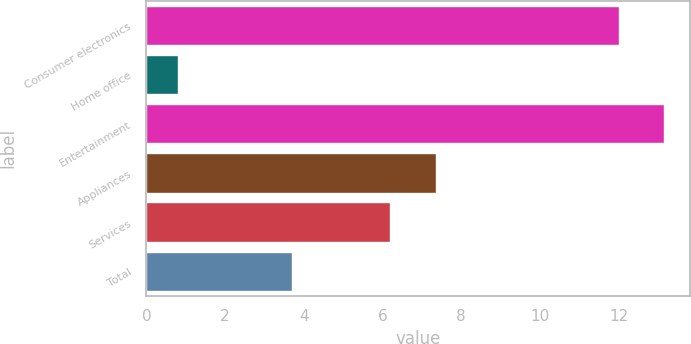<chart> <loc_0><loc_0><loc_500><loc_500><bar_chart><fcel>Consumer electronics<fcel>Home office<fcel>Entertainment<fcel>Appliances<fcel>Services<fcel>Total<nl><fcel>12<fcel>0.8<fcel>13.16<fcel>7.36<fcel>6.2<fcel>3.7<nl></chart> 